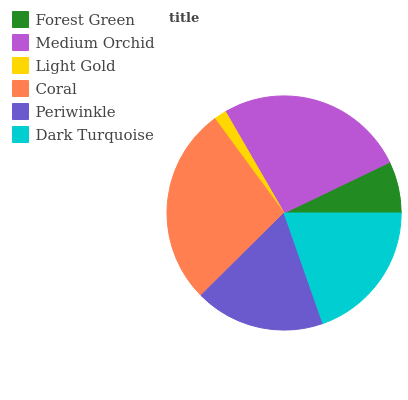Is Light Gold the minimum?
Answer yes or no. Yes. Is Coral the maximum?
Answer yes or no. Yes. Is Medium Orchid the minimum?
Answer yes or no. No. Is Medium Orchid the maximum?
Answer yes or no. No. Is Medium Orchid greater than Forest Green?
Answer yes or no. Yes. Is Forest Green less than Medium Orchid?
Answer yes or no. Yes. Is Forest Green greater than Medium Orchid?
Answer yes or no. No. Is Medium Orchid less than Forest Green?
Answer yes or no. No. Is Dark Turquoise the high median?
Answer yes or no. Yes. Is Periwinkle the low median?
Answer yes or no. Yes. Is Medium Orchid the high median?
Answer yes or no. No. Is Medium Orchid the low median?
Answer yes or no. No. 